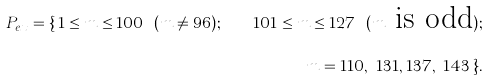<formula> <loc_0><loc_0><loc_500><loc_500>P _ { e x } = \{ \, 1 \leq m \leq 1 0 0 \ ( m \ne 9 6 ) ; \quad 1 0 1 \leq m \leq 1 2 7 \ ( m \text {   is odd} ) ; \\ m = 1 1 0 , \ 1 3 1 , 1 3 7 , \ 1 4 3 \, \} .</formula> 